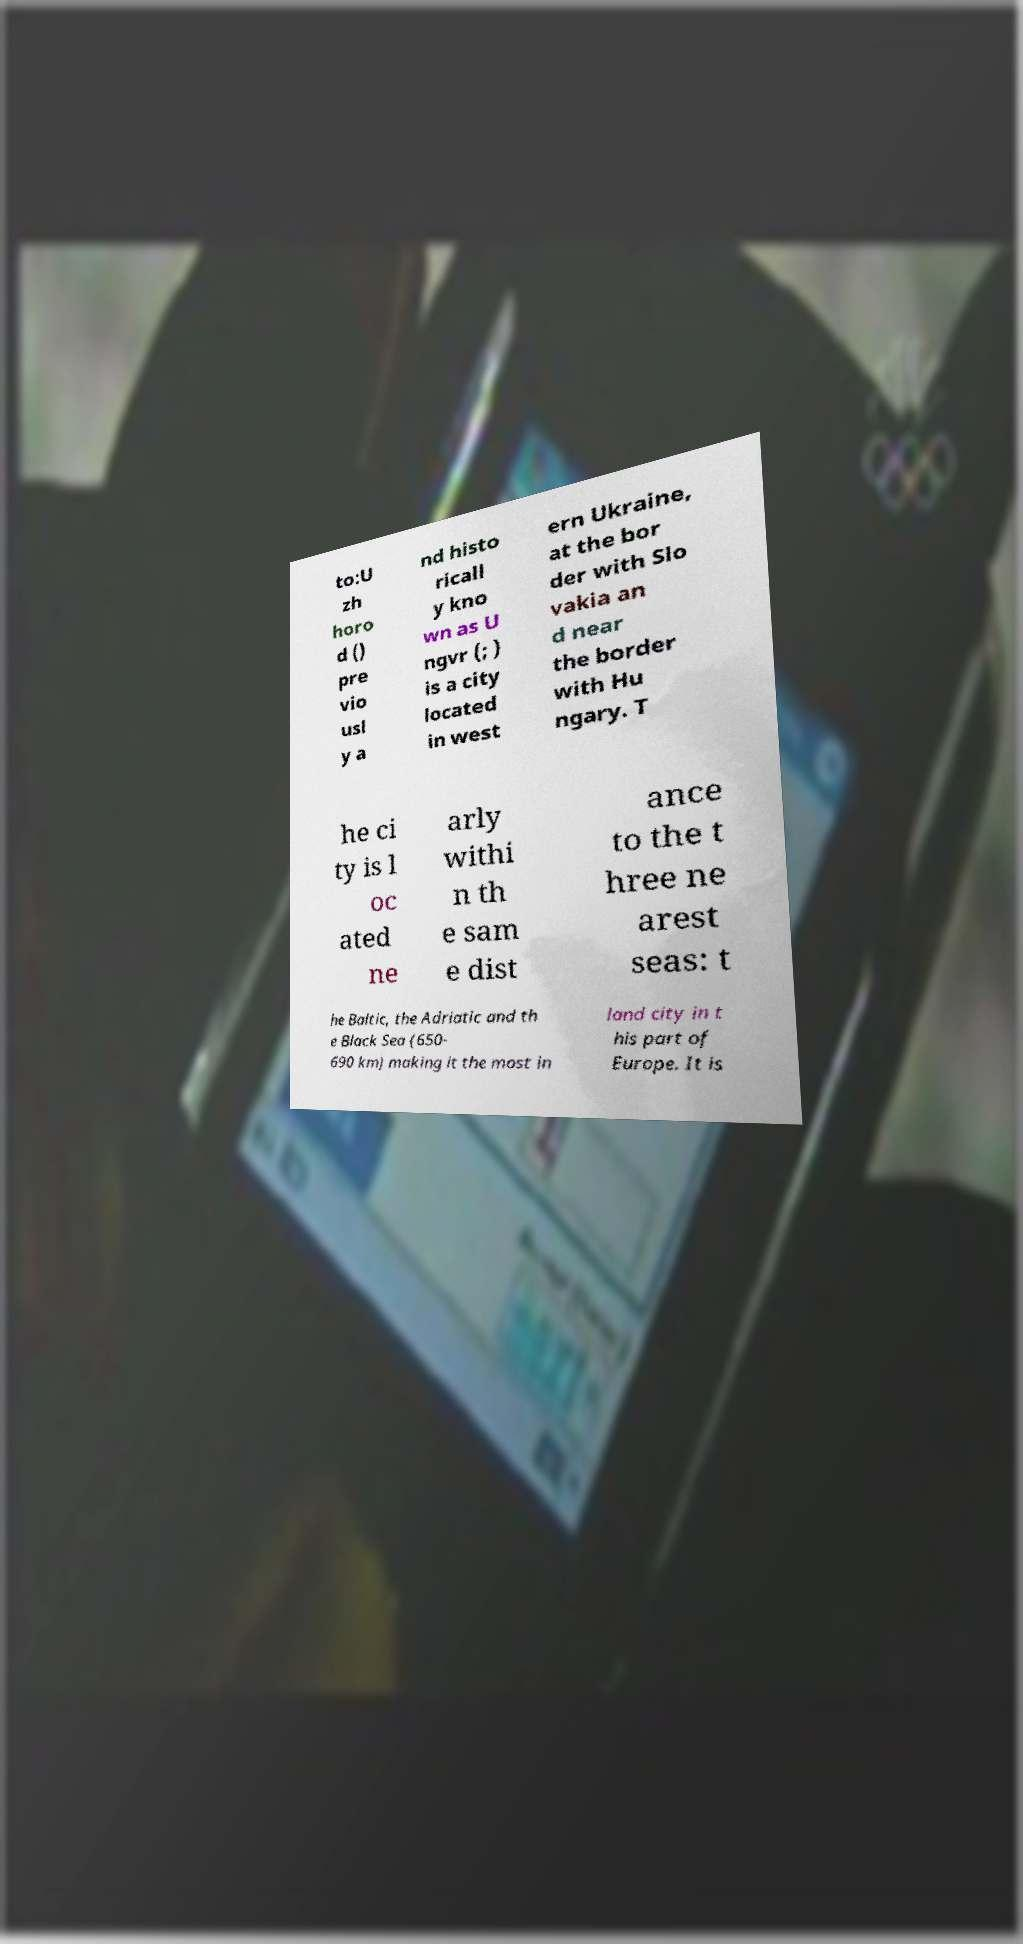Can you accurately transcribe the text from the provided image for me? to:U zh horo d () pre vio usl y a nd histo ricall y kno wn as U ngvr (; ) is a city located in west ern Ukraine, at the bor der with Slo vakia an d near the border with Hu ngary. T he ci ty is l oc ated ne arly withi n th e sam e dist ance to the t hree ne arest seas: t he Baltic, the Adriatic and th e Black Sea (650- 690 km) making it the most in land city in t his part of Europe. It is 